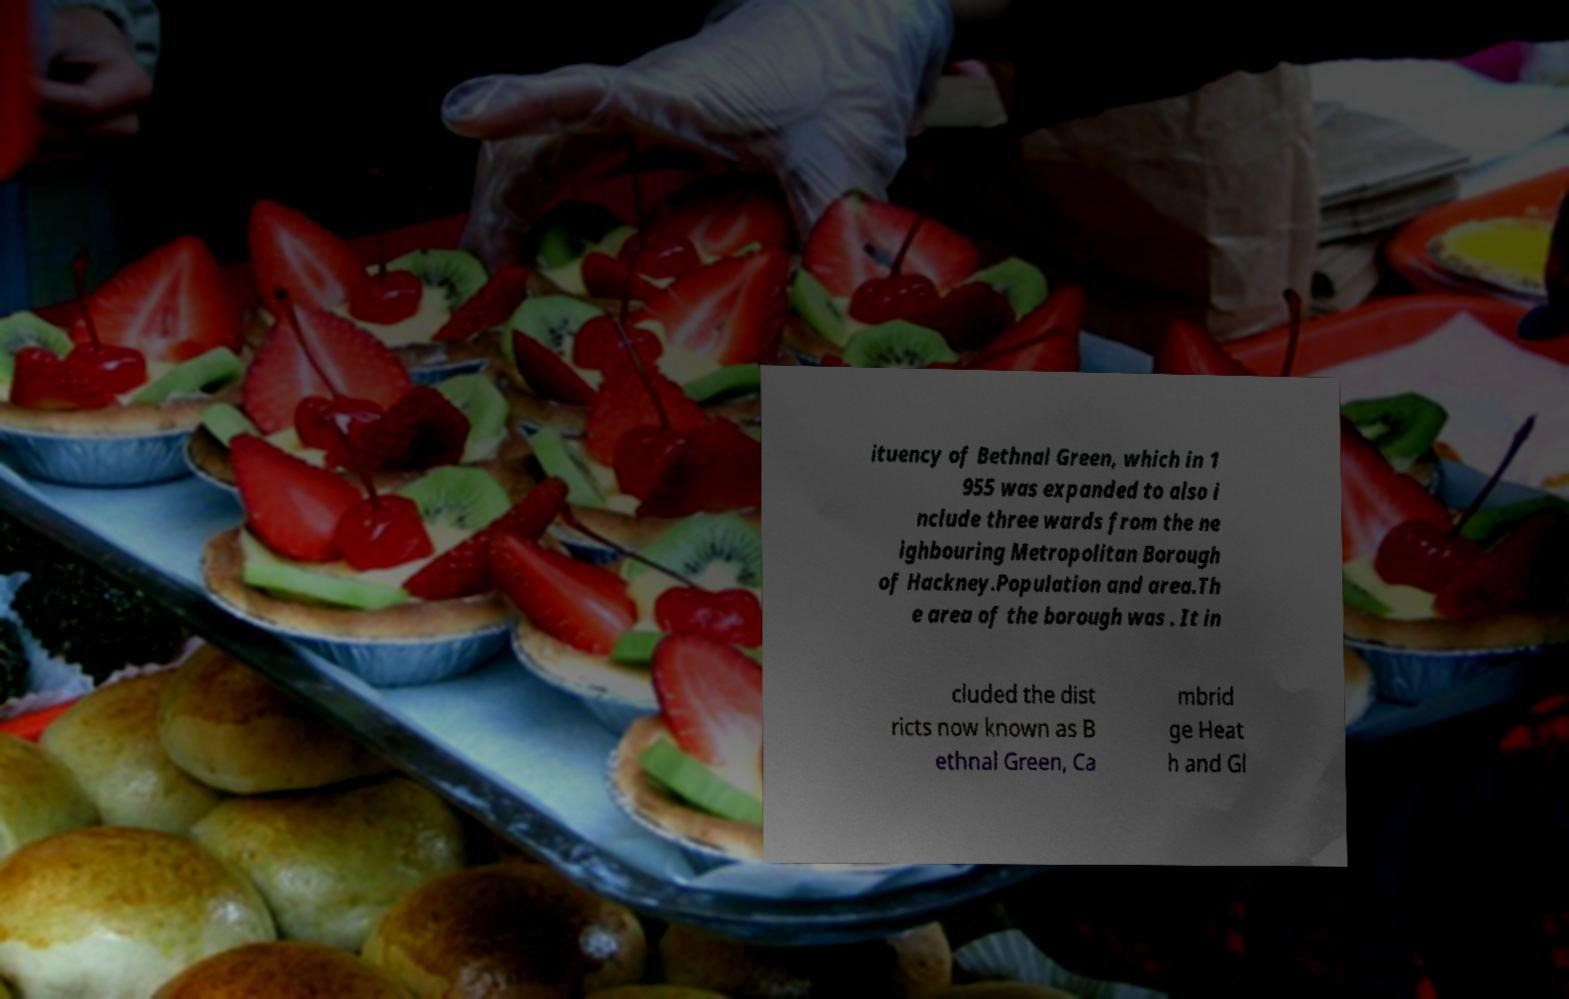Please identify and transcribe the text found in this image. ituency of Bethnal Green, which in 1 955 was expanded to also i nclude three wards from the ne ighbouring Metropolitan Borough of Hackney.Population and area.Th e area of the borough was . It in cluded the dist ricts now known as B ethnal Green, Ca mbrid ge Heat h and Gl 